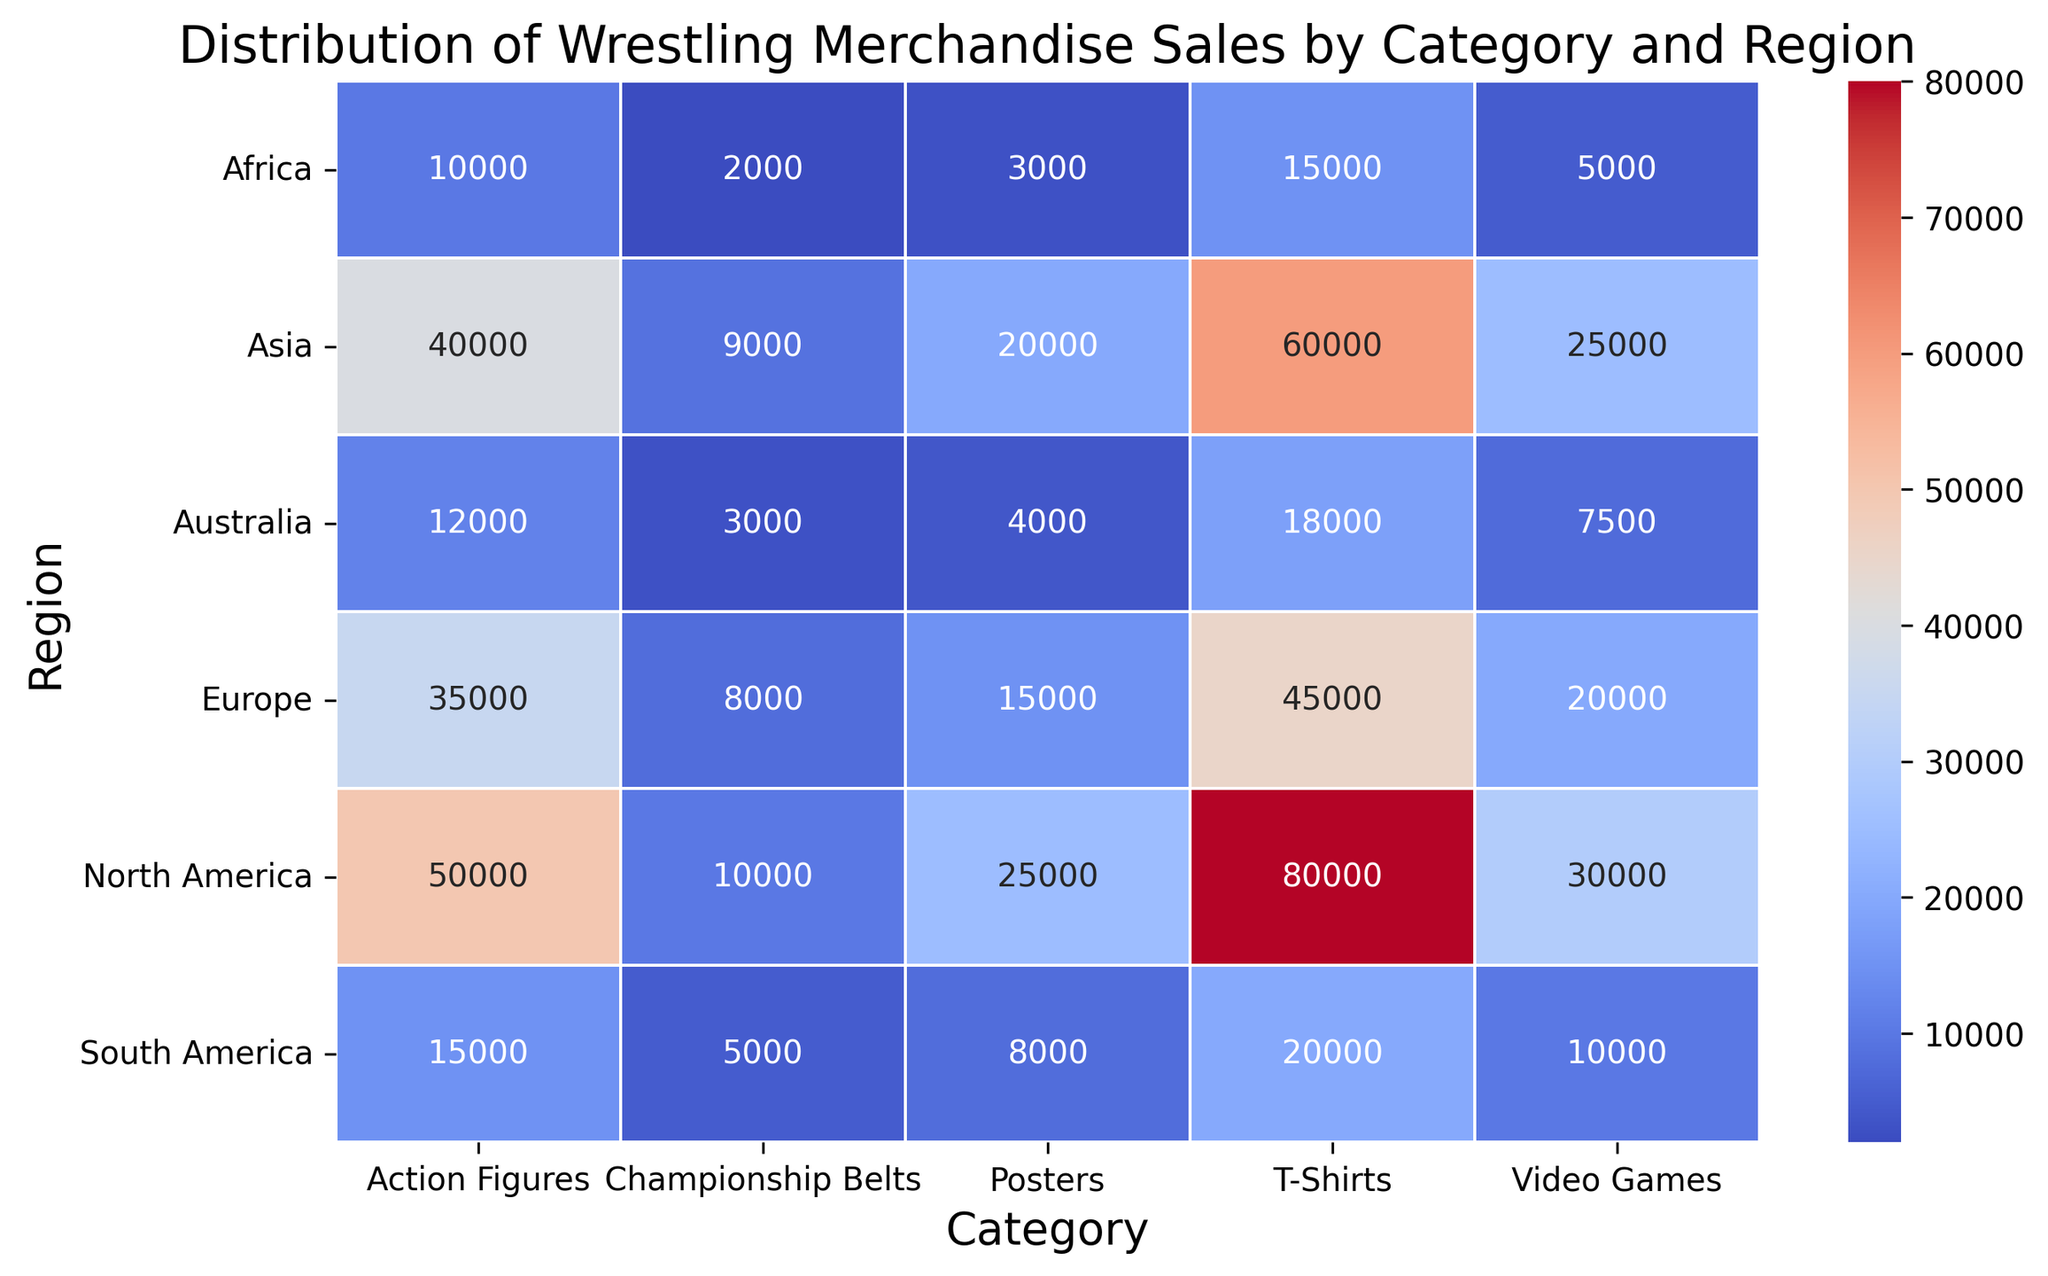Which region has the highest sales for T-Shirts? Look for the cell in the T-Shirts column with the darkest shade (indicating the highest sales) and match it with its row (i.e., the region). North America shows the darkest shade for T-Shirts.
Answer: North America Which category has the lowest sales in Africa? Locate the row for Africa and identify the cell with the lightest shade, which represents the lowest sales within that row. Championship Belts has the lightest shade in Africa.
Answer: Championship Belts Which region has the most balanced distribution of sales across all categories? Assess the consistency of shades within each region's row. The region with similar shades across all categories is considered the most balanced. Australia shows a relatively consistent pattern in shades.
Answer: Australia What is the total sales of Championship Belts across all regions? Sum the sales of Championship Belts in each region (10000 + 8000 + 9000 + 5000 + 2000 + 3000). This adds up to 37000.
Answer: 37000 Which category has the biggest difference in sales between North America and South America? Calculate the difference in sales between North America and South America for each category and find the maximum difference. T-Shirts have the biggest difference (80000 - 20000 = 60000).
Answer: T-Shirts What is the average sales of Action Figures in Europe and Asia? Calculate the average by adding sales of Action Figures in Europe and Asia and dividing by 2 ((35000 + 40000)/2 = 37500).
Answer: 37500 Which category has the highest visual contrast in colors within the heatmap? Identify the category with the widest range of colors from light to dark shades. Action Figures show the widest range, indicating the highest sales contrast across regions.
Answer: Action Figures Which region contributes the least to overall sales? Find the region with the lightest shades overall when summing up the sales for all categories. Africa consistently shows lighter shades across all categories.
Answer: Africa How does the sales of posters in Asia compare to those in Europe? Compare the shades of the Posters cell in Asia and Europe. Asia has a darker shade at 20000, compared to Europe's 15000.
Answer: Asia has higher sales What is the sum of sales for T-Shirts and Video Games in North America? Add up the sales values for T-Shirts and Video Games in North America (80000 + 30000 = 110000).
Answer: 110000 